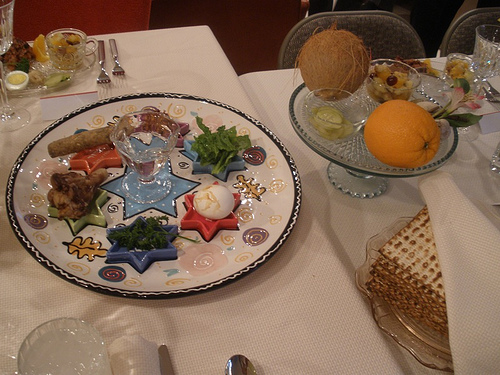Imagine a fantastical scenario where the items on the plate come to life. In a whimsical twist, imagine the items on the plate spring to life. The hard-boiled egg transforms into a wise, old sage offering cryptic advice. The bitter herbs become tiny dancers, performing a jittery jig that tells the story of ancient struggles. The fresh greens sprout legs and arms, encouraging everyone to join in a festive, leafy parade. The matzo sheets flap like wings, lifting spirits and spreading joy. The orange and the coconut engage in a juggling act, mesmerizing all who watch with their playful antics. It's a delightful spectacle where food and tradition merge into a living, breathing celebration. 